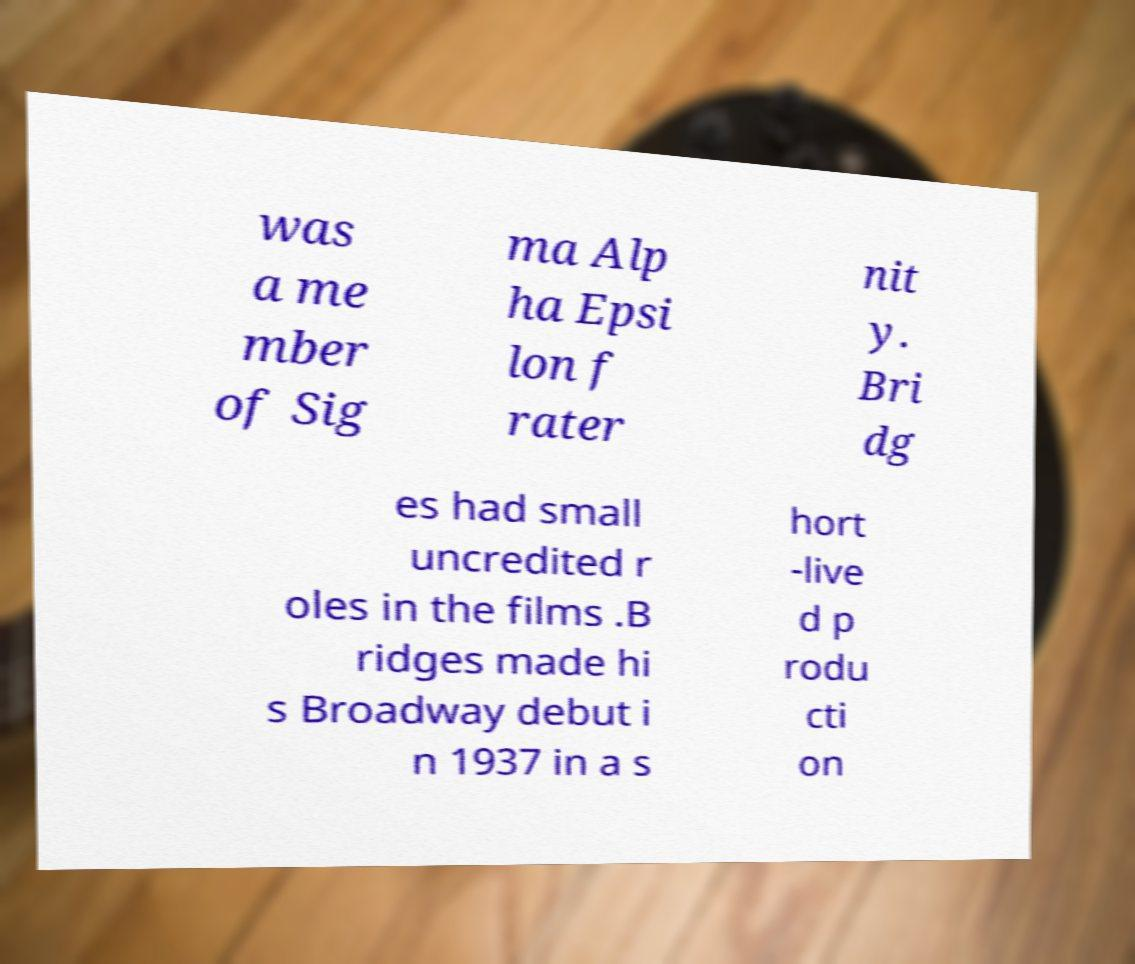What messages or text are displayed in this image? I need them in a readable, typed format. was a me mber of Sig ma Alp ha Epsi lon f rater nit y. Bri dg es had small uncredited r oles in the films .B ridges made hi s Broadway debut i n 1937 in a s hort -live d p rodu cti on 